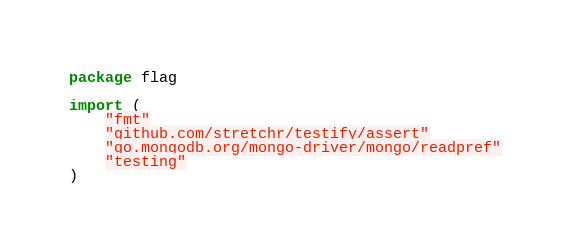Convert code to text. <code><loc_0><loc_0><loc_500><loc_500><_Go_>package flag

import (
	"fmt"
	"github.com/stretchr/testify/assert"
	"go.mongodb.org/mongo-driver/mongo/readpref"
	"testing"
)
</code> 